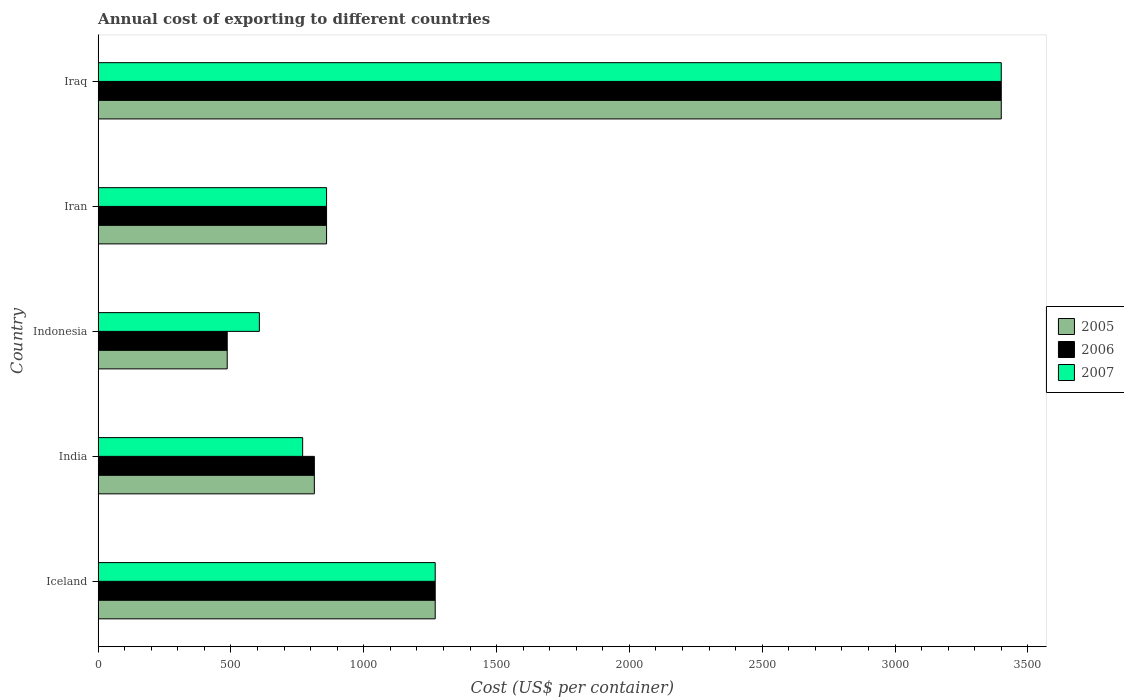Are the number of bars per tick equal to the number of legend labels?
Provide a short and direct response. Yes. In how many cases, is the number of bars for a given country not equal to the number of legend labels?
Your answer should be compact. 0. What is the total annual cost of exporting in 2006 in India?
Keep it short and to the point. 814. Across all countries, what is the maximum total annual cost of exporting in 2005?
Offer a very short reply. 3400. Across all countries, what is the minimum total annual cost of exporting in 2006?
Provide a short and direct response. 486. In which country was the total annual cost of exporting in 2006 maximum?
Keep it short and to the point. Iraq. In which country was the total annual cost of exporting in 2006 minimum?
Give a very brief answer. Indonesia. What is the total total annual cost of exporting in 2007 in the graph?
Your answer should be very brief. 6906. What is the difference between the total annual cost of exporting in 2006 in Iceland and that in Indonesia?
Your response must be concise. 783. What is the difference between the total annual cost of exporting in 2005 in Iceland and the total annual cost of exporting in 2006 in Indonesia?
Your answer should be very brief. 783. What is the average total annual cost of exporting in 2006 per country?
Your answer should be very brief. 1365.8. What is the ratio of the total annual cost of exporting in 2007 in Indonesia to that in Iraq?
Make the answer very short. 0.18. Is the difference between the total annual cost of exporting in 2006 in Iran and Iraq greater than the difference between the total annual cost of exporting in 2005 in Iran and Iraq?
Make the answer very short. No. What is the difference between the highest and the second highest total annual cost of exporting in 2006?
Your answer should be very brief. 2131. What is the difference between the highest and the lowest total annual cost of exporting in 2006?
Offer a terse response. 2914. Is the sum of the total annual cost of exporting in 2005 in India and Indonesia greater than the maximum total annual cost of exporting in 2007 across all countries?
Provide a succinct answer. No. What does the 3rd bar from the bottom in India represents?
Make the answer very short. 2007. Are all the bars in the graph horizontal?
Offer a terse response. Yes. How many countries are there in the graph?
Provide a short and direct response. 5. Does the graph contain any zero values?
Provide a short and direct response. No. Does the graph contain grids?
Offer a very short reply. No. How are the legend labels stacked?
Provide a short and direct response. Vertical. What is the title of the graph?
Offer a terse response. Annual cost of exporting to different countries. Does "1967" appear as one of the legend labels in the graph?
Your answer should be compact. No. What is the label or title of the X-axis?
Make the answer very short. Cost (US$ per container). What is the label or title of the Y-axis?
Your answer should be very brief. Country. What is the Cost (US$ per container) in 2005 in Iceland?
Keep it short and to the point. 1269. What is the Cost (US$ per container) in 2006 in Iceland?
Your response must be concise. 1269. What is the Cost (US$ per container) in 2007 in Iceland?
Provide a succinct answer. 1269. What is the Cost (US$ per container) of 2005 in India?
Your answer should be compact. 814. What is the Cost (US$ per container) of 2006 in India?
Ensure brevity in your answer.  814. What is the Cost (US$ per container) in 2007 in India?
Offer a terse response. 770. What is the Cost (US$ per container) in 2005 in Indonesia?
Make the answer very short. 486. What is the Cost (US$ per container) in 2006 in Indonesia?
Make the answer very short. 486. What is the Cost (US$ per container) of 2007 in Indonesia?
Offer a very short reply. 607. What is the Cost (US$ per container) in 2005 in Iran?
Offer a very short reply. 860. What is the Cost (US$ per container) in 2006 in Iran?
Make the answer very short. 860. What is the Cost (US$ per container) in 2007 in Iran?
Ensure brevity in your answer.  860. What is the Cost (US$ per container) of 2005 in Iraq?
Your answer should be compact. 3400. What is the Cost (US$ per container) in 2006 in Iraq?
Your response must be concise. 3400. What is the Cost (US$ per container) of 2007 in Iraq?
Give a very brief answer. 3400. Across all countries, what is the maximum Cost (US$ per container) in 2005?
Your response must be concise. 3400. Across all countries, what is the maximum Cost (US$ per container) of 2006?
Offer a very short reply. 3400. Across all countries, what is the maximum Cost (US$ per container) of 2007?
Offer a very short reply. 3400. Across all countries, what is the minimum Cost (US$ per container) of 2005?
Make the answer very short. 486. Across all countries, what is the minimum Cost (US$ per container) in 2006?
Offer a very short reply. 486. Across all countries, what is the minimum Cost (US$ per container) of 2007?
Your response must be concise. 607. What is the total Cost (US$ per container) of 2005 in the graph?
Ensure brevity in your answer.  6829. What is the total Cost (US$ per container) in 2006 in the graph?
Provide a short and direct response. 6829. What is the total Cost (US$ per container) of 2007 in the graph?
Ensure brevity in your answer.  6906. What is the difference between the Cost (US$ per container) in 2005 in Iceland and that in India?
Your answer should be compact. 455. What is the difference between the Cost (US$ per container) of 2006 in Iceland and that in India?
Make the answer very short. 455. What is the difference between the Cost (US$ per container) of 2007 in Iceland and that in India?
Ensure brevity in your answer.  499. What is the difference between the Cost (US$ per container) of 2005 in Iceland and that in Indonesia?
Provide a short and direct response. 783. What is the difference between the Cost (US$ per container) in 2006 in Iceland and that in Indonesia?
Keep it short and to the point. 783. What is the difference between the Cost (US$ per container) in 2007 in Iceland and that in Indonesia?
Offer a terse response. 662. What is the difference between the Cost (US$ per container) in 2005 in Iceland and that in Iran?
Provide a succinct answer. 409. What is the difference between the Cost (US$ per container) of 2006 in Iceland and that in Iran?
Your response must be concise. 409. What is the difference between the Cost (US$ per container) of 2007 in Iceland and that in Iran?
Provide a short and direct response. 409. What is the difference between the Cost (US$ per container) of 2005 in Iceland and that in Iraq?
Ensure brevity in your answer.  -2131. What is the difference between the Cost (US$ per container) in 2006 in Iceland and that in Iraq?
Provide a short and direct response. -2131. What is the difference between the Cost (US$ per container) of 2007 in Iceland and that in Iraq?
Your answer should be compact. -2131. What is the difference between the Cost (US$ per container) in 2005 in India and that in Indonesia?
Provide a short and direct response. 328. What is the difference between the Cost (US$ per container) of 2006 in India and that in Indonesia?
Ensure brevity in your answer.  328. What is the difference between the Cost (US$ per container) of 2007 in India and that in Indonesia?
Ensure brevity in your answer.  163. What is the difference between the Cost (US$ per container) of 2005 in India and that in Iran?
Provide a short and direct response. -46. What is the difference between the Cost (US$ per container) of 2006 in India and that in Iran?
Offer a terse response. -46. What is the difference between the Cost (US$ per container) of 2007 in India and that in Iran?
Provide a succinct answer. -90. What is the difference between the Cost (US$ per container) in 2005 in India and that in Iraq?
Keep it short and to the point. -2586. What is the difference between the Cost (US$ per container) in 2006 in India and that in Iraq?
Offer a terse response. -2586. What is the difference between the Cost (US$ per container) of 2007 in India and that in Iraq?
Ensure brevity in your answer.  -2630. What is the difference between the Cost (US$ per container) of 2005 in Indonesia and that in Iran?
Provide a short and direct response. -374. What is the difference between the Cost (US$ per container) of 2006 in Indonesia and that in Iran?
Your response must be concise. -374. What is the difference between the Cost (US$ per container) of 2007 in Indonesia and that in Iran?
Keep it short and to the point. -253. What is the difference between the Cost (US$ per container) of 2005 in Indonesia and that in Iraq?
Keep it short and to the point. -2914. What is the difference between the Cost (US$ per container) in 2006 in Indonesia and that in Iraq?
Your answer should be very brief. -2914. What is the difference between the Cost (US$ per container) of 2007 in Indonesia and that in Iraq?
Give a very brief answer. -2793. What is the difference between the Cost (US$ per container) of 2005 in Iran and that in Iraq?
Ensure brevity in your answer.  -2540. What is the difference between the Cost (US$ per container) in 2006 in Iran and that in Iraq?
Provide a short and direct response. -2540. What is the difference between the Cost (US$ per container) in 2007 in Iran and that in Iraq?
Keep it short and to the point. -2540. What is the difference between the Cost (US$ per container) in 2005 in Iceland and the Cost (US$ per container) in 2006 in India?
Ensure brevity in your answer.  455. What is the difference between the Cost (US$ per container) in 2005 in Iceland and the Cost (US$ per container) in 2007 in India?
Keep it short and to the point. 499. What is the difference between the Cost (US$ per container) of 2006 in Iceland and the Cost (US$ per container) of 2007 in India?
Offer a very short reply. 499. What is the difference between the Cost (US$ per container) of 2005 in Iceland and the Cost (US$ per container) of 2006 in Indonesia?
Provide a short and direct response. 783. What is the difference between the Cost (US$ per container) in 2005 in Iceland and the Cost (US$ per container) in 2007 in Indonesia?
Offer a very short reply. 662. What is the difference between the Cost (US$ per container) in 2006 in Iceland and the Cost (US$ per container) in 2007 in Indonesia?
Offer a very short reply. 662. What is the difference between the Cost (US$ per container) of 2005 in Iceland and the Cost (US$ per container) of 2006 in Iran?
Your response must be concise. 409. What is the difference between the Cost (US$ per container) of 2005 in Iceland and the Cost (US$ per container) of 2007 in Iran?
Offer a very short reply. 409. What is the difference between the Cost (US$ per container) of 2006 in Iceland and the Cost (US$ per container) of 2007 in Iran?
Your response must be concise. 409. What is the difference between the Cost (US$ per container) in 2005 in Iceland and the Cost (US$ per container) in 2006 in Iraq?
Provide a short and direct response. -2131. What is the difference between the Cost (US$ per container) of 2005 in Iceland and the Cost (US$ per container) of 2007 in Iraq?
Your answer should be very brief. -2131. What is the difference between the Cost (US$ per container) in 2006 in Iceland and the Cost (US$ per container) in 2007 in Iraq?
Offer a terse response. -2131. What is the difference between the Cost (US$ per container) of 2005 in India and the Cost (US$ per container) of 2006 in Indonesia?
Provide a succinct answer. 328. What is the difference between the Cost (US$ per container) in 2005 in India and the Cost (US$ per container) in 2007 in Indonesia?
Provide a succinct answer. 207. What is the difference between the Cost (US$ per container) of 2006 in India and the Cost (US$ per container) of 2007 in Indonesia?
Offer a very short reply. 207. What is the difference between the Cost (US$ per container) in 2005 in India and the Cost (US$ per container) in 2006 in Iran?
Provide a succinct answer. -46. What is the difference between the Cost (US$ per container) in 2005 in India and the Cost (US$ per container) in 2007 in Iran?
Make the answer very short. -46. What is the difference between the Cost (US$ per container) in 2006 in India and the Cost (US$ per container) in 2007 in Iran?
Ensure brevity in your answer.  -46. What is the difference between the Cost (US$ per container) in 2005 in India and the Cost (US$ per container) in 2006 in Iraq?
Your answer should be very brief. -2586. What is the difference between the Cost (US$ per container) in 2005 in India and the Cost (US$ per container) in 2007 in Iraq?
Ensure brevity in your answer.  -2586. What is the difference between the Cost (US$ per container) in 2006 in India and the Cost (US$ per container) in 2007 in Iraq?
Ensure brevity in your answer.  -2586. What is the difference between the Cost (US$ per container) in 2005 in Indonesia and the Cost (US$ per container) in 2006 in Iran?
Offer a terse response. -374. What is the difference between the Cost (US$ per container) of 2005 in Indonesia and the Cost (US$ per container) of 2007 in Iran?
Your answer should be compact. -374. What is the difference between the Cost (US$ per container) of 2006 in Indonesia and the Cost (US$ per container) of 2007 in Iran?
Your response must be concise. -374. What is the difference between the Cost (US$ per container) of 2005 in Indonesia and the Cost (US$ per container) of 2006 in Iraq?
Your response must be concise. -2914. What is the difference between the Cost (US$ per container) in 2005 in Indonesia and the Cost (US$ per container) in 2007 in Iraq?
Give a very brief answer. -2914. What is the difference between the Cost (US$ per container) in 2006 in Indonesia and the Cost (US$ per container) in 2007 in Iraq?
Your response must be concise. -2914. What is the difference between the Cost (US$ per container) of 2005 in Iran and the Cost (US$ per container) of 2006 in Iraq?
Your answer should be compact. -2540. What is the difference between the Cost (US$ per container) of 2005 in Iran and the Cost (US$ per container) of 2007 in Iraq?
Offer a very short reply. -2540. What is the difference between the Cost (US$ per container) of 2006 in Iran and the Cost (US$ per container) of 2007 in Iraq?
Offer a terse response. -2540. What is the average Cost (US$ per container) of 2005 per country?
Your answer should be very brief. 1365.8. What is the average Cost (US$ per container) of 2006 per country?
Ensure brevity in your answer.  1365.8. What is the average Cost (US$ per container) in 2007 per country?
Keep it short and to the point. 1381.2. What is the difference between the Cost (US$ per container) in 2005 and Cost (US$ per container) in 2007 in Iceland?
Give a very brief answer. 0. What is the difference between the Cost (US$ per container) of 2005 and Cost (US$ per container) of 2006 in India?
Ensure brevity in your answer.  0. What is the difference between the Cost (US$ per container) in 2006 and Cost (US$ per container) in 2007 in India?
Keep it short and to the point. 44. What is the difference between the Cost (US$ per container) of 2005 and Cost (US$ per container) of 2007 in Indonesia?
Provide a short and direct response. -121. What is the difference between the Cost (US$ per container) in 2006 and Cost (US$ per container) in 2007 in Indonesia?
Ensure brevity in your answer.  -121. What is the difference between the Cost (US$ per container) in 2005 and Cost (US$ per container) in 2006 in Iran?
Provide a short and direct response. 0. What is the difference between the Cost (US$ per container) in 2005 and Cost (US$ per container) in 2007 in Iran?
Provide a succinct answer. 0. What is the difference between the Cost (US$ per container) of 2006 and Cost (US$ per container) of 2007 in Iran?
Make the answer very short. 0. What is the difference between the Cost (US$ per container) in 2006 and Cost (US$ per container) in 2007 in Iraq?
Keep it short and to the point. 0. What is the ratio of the Cost (US$ per container) in 2005 in Iceland to that in India?
Provide a succinct answer. 1.56. What is the ratio of the Cost (US$ per container) of 2006 in Iceland to that in India?
Your response must be concise. 1.56. What is the ratio of the Cost (US$ per container) in 2007 in Iceland to that in India?
Your answer should be compact. 1.65. What is the ratio of the Cost (US$ per container) in 2005 in Iceland to that in Indonesia?
Your answer should be very brief. 2.61. What is the ratio of the Cost (US$ per container) of 2006 in Iceland to that in Indonesia?
Your answer should be compact. 2.61. What is the ratio of the Cost (US$ per container) of 2007 in Iceland to that in Indonesia?
Give a very brief answer. 2.09. What is the ratio of the Cost (US$ per container) in 2005 in Iceland to that in Iran?
Keep it short and to the point. 1.48. What is the ratio of the Cost (US$ per container) in 2006 in Iceland to that in Iran?
Make the answer very short. 1.48. What is the ratio of the Cost (US$ per container) of 2007 in Iceland to that in Iran?
Offer a very short reply. 1.48. What is the ratio of the Cost (US$ per container) in 2005 in Iceland to that in Iraq?
Offer a terse response. 0.37. What is the ratio of the Cost (US$ per container) in 2006 in Iceland to that in Iraq?
Keep it short and to the point. 0.37. What is the ratio of the Cost (US$ per container) of 2007 in Iceland to that in Iraq?
Provide a short and direct response. 0.37. What is the ratio of the Cost (US$ per container) in 2005 in India to that in Indonesia?
Your answer should be very brief. 1.67. What is the ratio of the Cost (US$ per container) of 2006 in India to that in Indonesia?
Provide a succinct answer. 1.67. What is the ratio of the Cost (US$ per container) of 2007 in India to that in Indonesia?
Make the answer very short. 1.27. What is the ratio of the Cost (US$ per container) in 2005 in India to that in Iran?
Keep it short and to the point. 0.95. What is the ratio of the Cost (US$ per container) of 2006 in India to that in Iran?
Offer a very short reply. 0.95. What is the ratio of the Cost (US$ per container) of 2007 in India to that in Iran?
Provide a short and direct response. 0.9. What is the ratio of the Cost (US$ per container) of 2005 in India to that in Iraq?
Provide a succinct answer. 0.24. What is the ratio of the Cost (US$ per container) of 2006 in India to that in Iraq?
Ensure brevity in your answer.  0.24. What is the ratio of the Cost (US$ per container) in 2007 in India to that in Iraq?
Offer a very short reply. 0.23. What is the ratio of the Cost (US$ per container) in 2005 in Indonesia to that in Iran?
Offer a very short reply. 0.57. What is the ratio of the Cost (US$ per container) in 2006 in Indonesia to that in Iran?
Your response must be concise. 0.57. What is the ratio of the Cost (US$ per container) of 2007 in Indonesia to that in Iran?
Your answer should be very brief. 0.71. What is the ratio of the Cost (US$ per container) of 2005 in Indonesia to that in Iraq?
Your answer should be very brief. 0.14. What is the ratio of the Cost (US$ per container) of 2006 in Indonesia to that in Iraq?
Your response must be concise. 0.14. What is the ratio of the Cost (US$ per container) in 2007 in Indonesia to that in Iraq?
Provide a short and direct response. 0.18. What is the ratio of the Cost (US$ per container) in 2005 in Iran to that in Iraq?
Ensure brevity in your answer.  0.25. What is the ratio of the Cost (US$ per container) in 2006 in Iran to that in Iraq?
Your answer should be very brief. 0.25. What is the ratio of the Cost (US$ per container) in 2007 in Iran to that in Iraq?
Provide a succinct answer. 0.25. What is the difference between the highest and the second highest Cost (US$ per container) of 2005?
Provide a succinct answer. 2131. What is the difference between the highest and the second highest Cost (US$ per container) in 2006?
Give a very brief answer. 2131. What is the difference between the highest and the second highest Cost (US$ per container) of 2007?
Give a very brief answer. 2131. What is the difference between the highest and the lowest Cost (US$ per container) of 2005?
Provide a succinct answer. 2914. What is the difference between the highest and the lowest Cost (US$ per container) of 2006?
Offer a very short reply. 2914. What is the difference between the highest and the lowest Cost (US$ per container) in 2007?
Keep it short and to the point. 2793. 